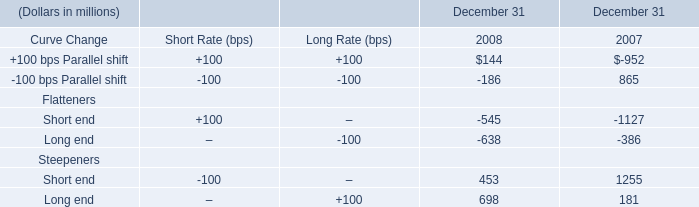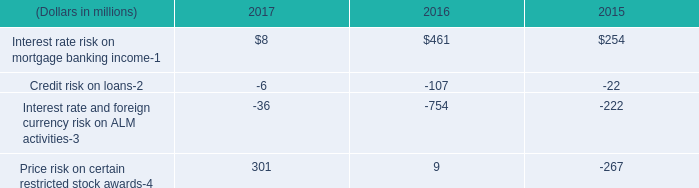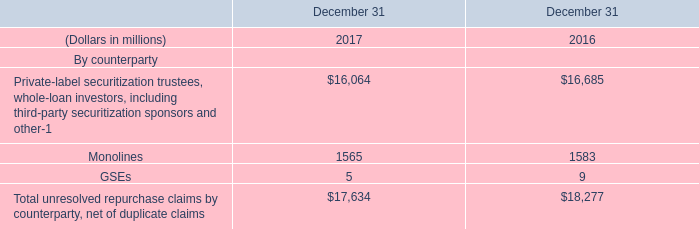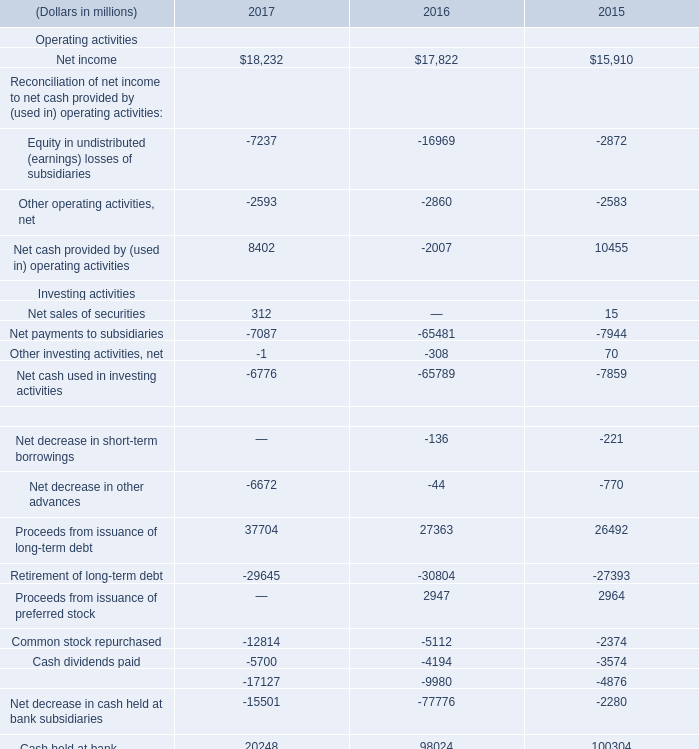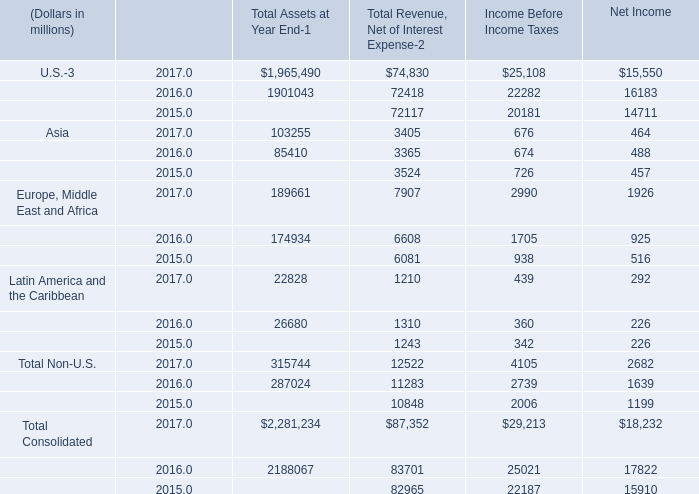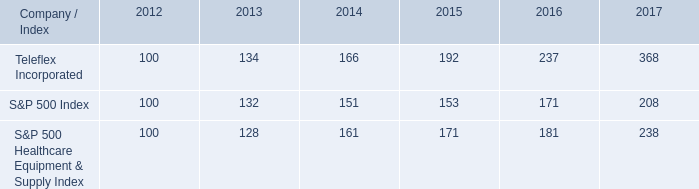What is the sum of Monolines of December 31 2016, and Net cash used in investing activities Investing activities of 2015 ? 
Computations: (1583.0 + 7859.0)
Answer: 9442.0. 